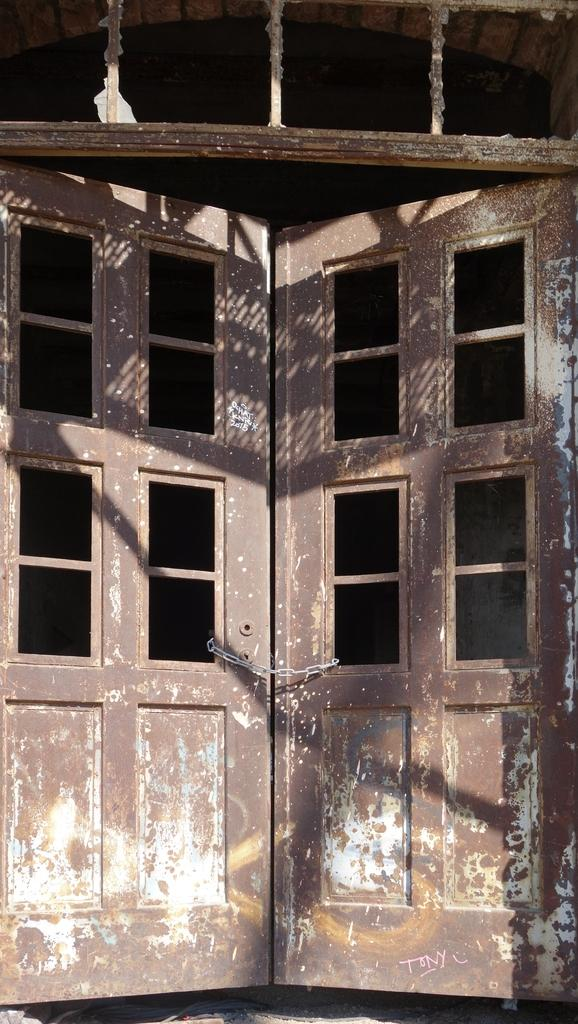What is located at the front of the image? There is a door in the front of the image. What can be seen at the top of the image? There is a window on the top of the image. What is the weight of the sofa in the image? There is no sofa present in the image, so it is not possible to determine its weight. 